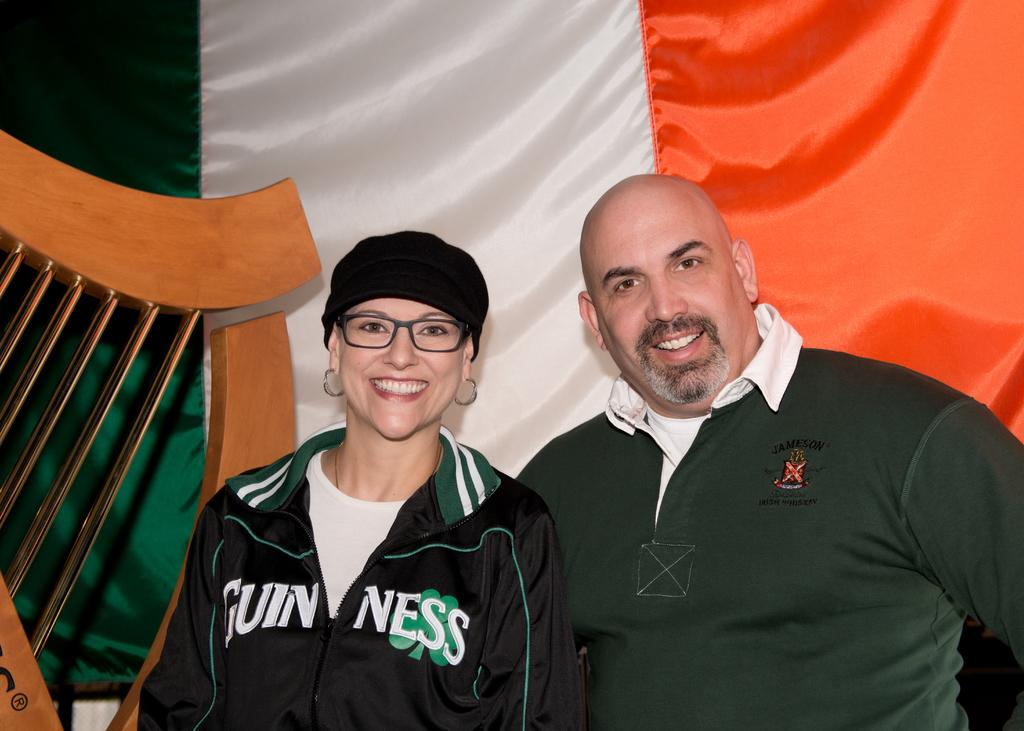How many people are present in the image? There is a man and a woman in the image. What can be seen in the background of the image? There is a multicolored curtain in the image. What is located on the left side of the image? There is a wooden object on the left side of the image. What type of swimsuit is the boy wearing in the image? There is no boy present in the image, and therefore no swimsuit can be observed. 